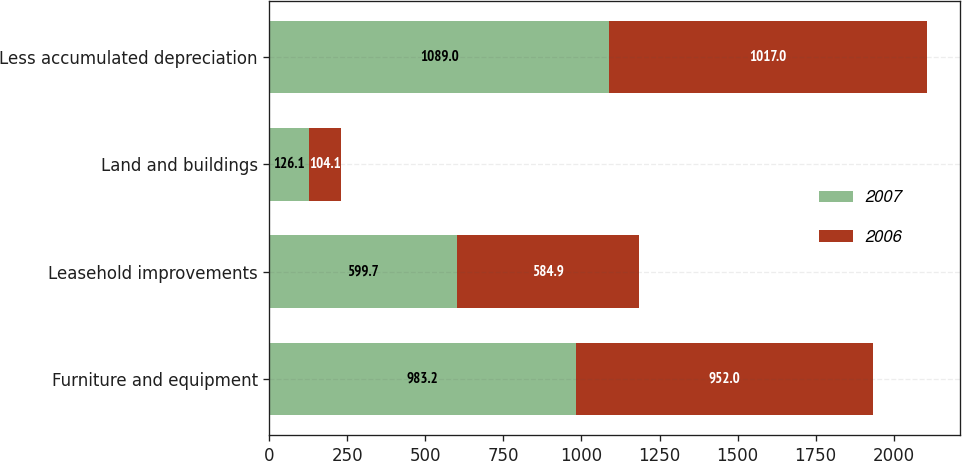<chart> <loc_0><loc_0><loc_500><loc_500><stacked_bar_chart><ecel><fcel>Furniture and equipment<fcel>Leasehold improvements<fcel>Land and buildings<fcel>Less accumulated depreciation<nl><fcel>2007<fcel>983.2<fcel>599.7<fcel>126.1<fcel>1089<nl><fcel>2006<fcel>952<fcel>584.9<fcel>104.1<fcel>1017<nl></chart> 